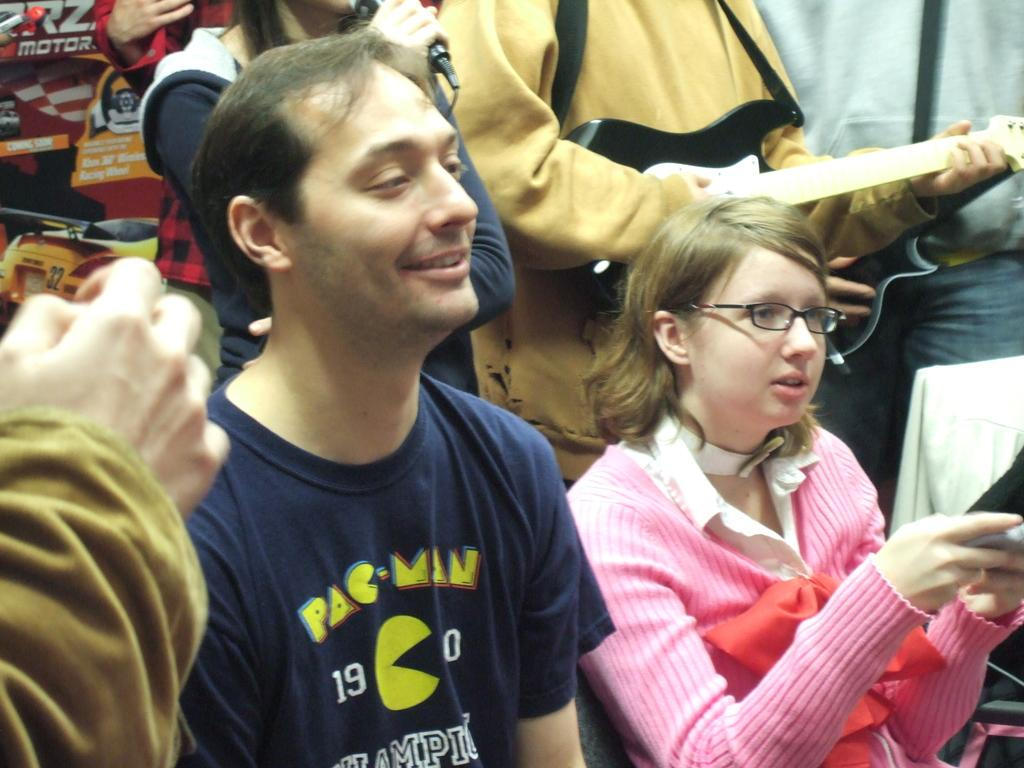What are the people in the front of the image doing? There are persons sitting in the front of the image. Can you describe the facial expression of one of the persons in the image? There is a person smiling in the image. What is happening in the background of the image? In the background of the image, there are persons standing. What are the persons in the background holding? The persons in the background are holding objects in their hands. What type of crook can be seen in the image? There is no crook present in the image. How does the heat affect the persons in the image? The provided facts do not mention any heat or temperature-related information, so we cannot determine how it affects the persons in the image. 